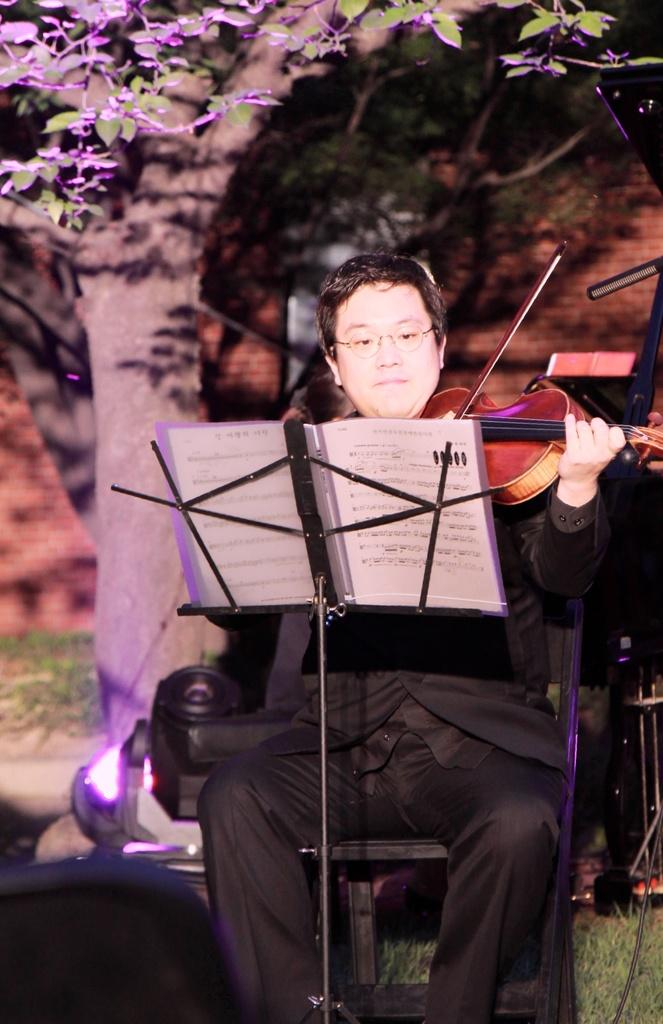What is the main subject of the image? The main subject of the image is a man. What is the man doing in the image? The man is seated and playing a violin. Where is the man located in the image? The man is under a tree. What object is in front of the man? There is a book on a book stand in front of the man. How many mice are hiding under the quilt in the image? There are no mice or quilt present in the image. What type of house is visible in the background of the image? There is no house visible in the background of the image. 